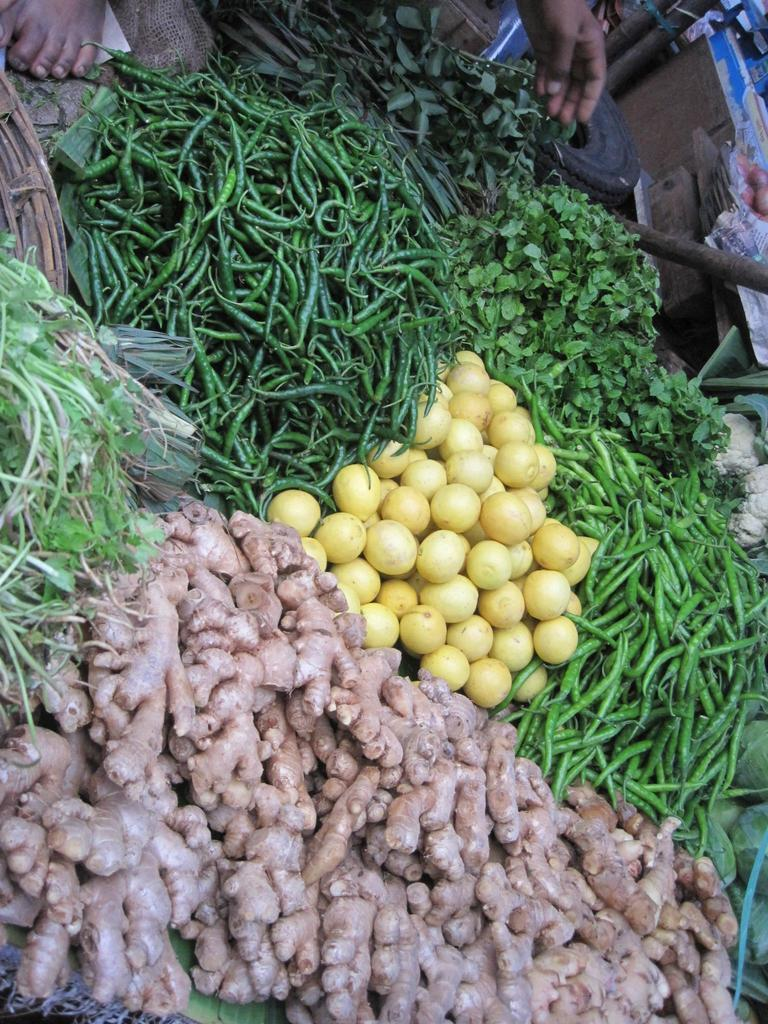What type of food can be seen in the image? There are vegetables in the image, including leafy vegetables. What other objects are present in the image? There is a tire, wooden objects, and other objects in the image. Can you describe the person's body parts visible in the image? A person's hand and leg are visible at the top of the image. What position does the person start in before they stop in the image? There is no person performing an action or changing positions in the image; only their hand and leg are visible. 